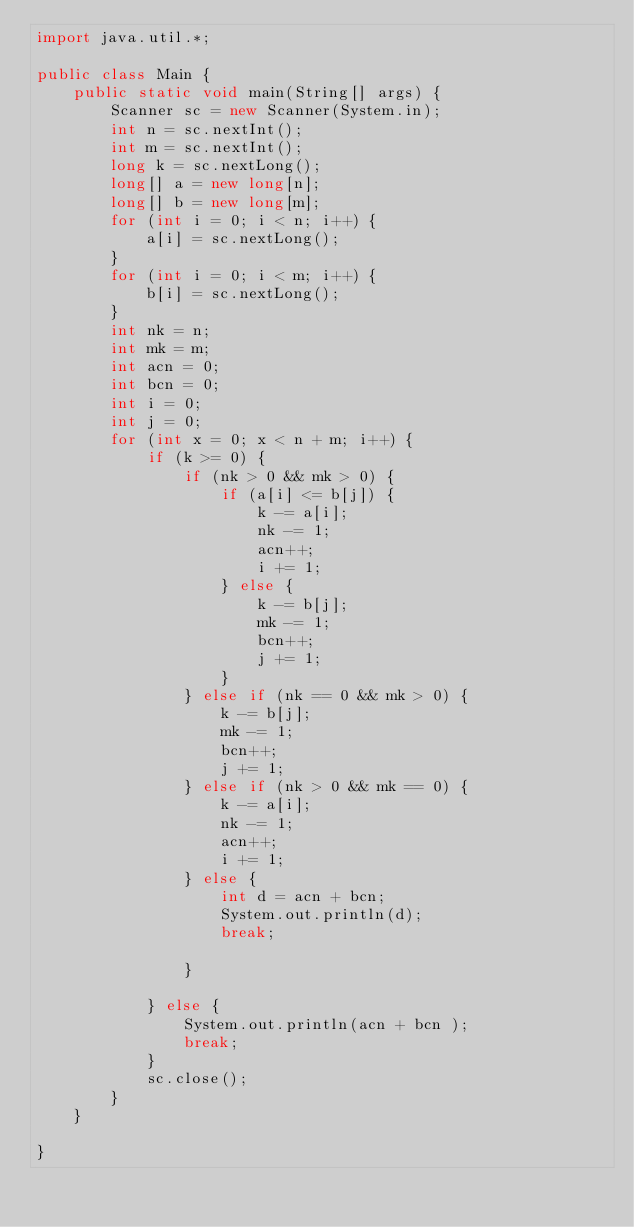<code> <loc_0><loc_0><loc_500><loc_500><_Java_>import java.util.*;

public class Main {
	public static void main(String[] args) {
		Scanner sc = new Scanner(System.in);
		int n = sc.nextInt();
		int m = sc.nextInt();
		long k = sc.nextLong();
		long[] a = new long[n];
		long[] b = new long[m];
		for (int i = 0; i < n; i++) {
			a[i] = sc.nextLong();
		}
		for (int i = 0; i < m; i++) {
			b[i] = sc.nextLong();
		}
		int nk = n;
		int mk = m;
		int acn = 0;
		int bcn = 0;
		int i = 0;
		int j = 0;
		for (int x = 0; x < n + m; i++) {
			if (k >= 0) {
				if (nk > 0 && mk > 0) {
					if (a[i] <= b[j]) {
						k -= a[i];
						nk -= 1;
						acn++;
						i += 1;
					} else {
						k -= b[j];
						mk -= 1;
						bcn++;
						j += 1;
					}
				} else if (nk == 0 && mk > 0) {
					k -= b[j];
					mk -= 1;
					bcn++;
					j += 1;
				} else if (nk > 0 && mk == 0) {
					k -= a[i];
					nk -= 1;
					acn++;
					i += 1;
				} else {
					int d = acn + bcn;
					System.out.println(d);
					break;

				}

			} else {
				System.out.println(acn + bcn );
				break;
			}
			sc.close();
		}
	}

}</code> 